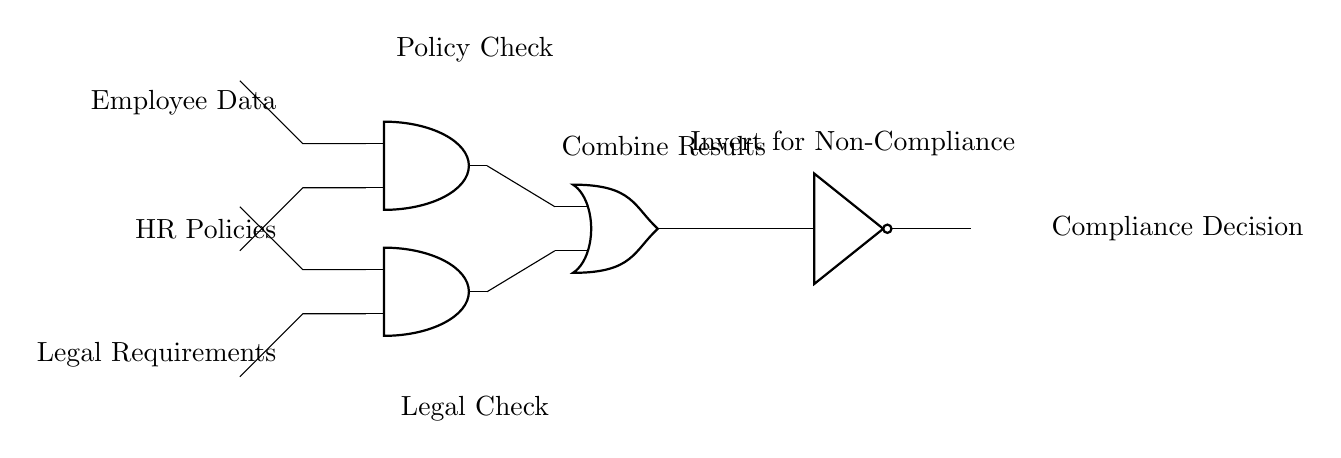What are the inputs to the AND gates? The inputs to the AND gates are Employee Data and HR Policies for the first AND gate, and Employee Data and Legal Requirements for the second AND gate.
Answer: Employee Data, HR Policies; Employee Data, Legal Requirements What is the function of the OR gate in this circuit? The OR gate combines the outputs of the two AND gates, producing a positive compliance decision if either of the AND gate outputs is true.
Answer: Combine results What does the NOT gate do in this circuit? The NOT gate inverts the output of the OR gate, indicating non-compliance if the OR gate output is true.
Answer: Invert for Non-Compliance How many AND gates are present in this circuit? There are two AND gates present in the circuit, one connected to the HR Policies and another to the Legal Requirements.
Answer: Two What is the final output of the logic gates? The final output is the Compliance Decision, which signifies whether the policies comply with the requirements after processing through the circuit.
Answer: Compliance Decision What would be the compliance decision if both AND gates output false? If both AND gates output false, the output of the OR gate would also be false, leading the NOT gate to output true indicating non-compliance.
Answer: Non-Compliance 